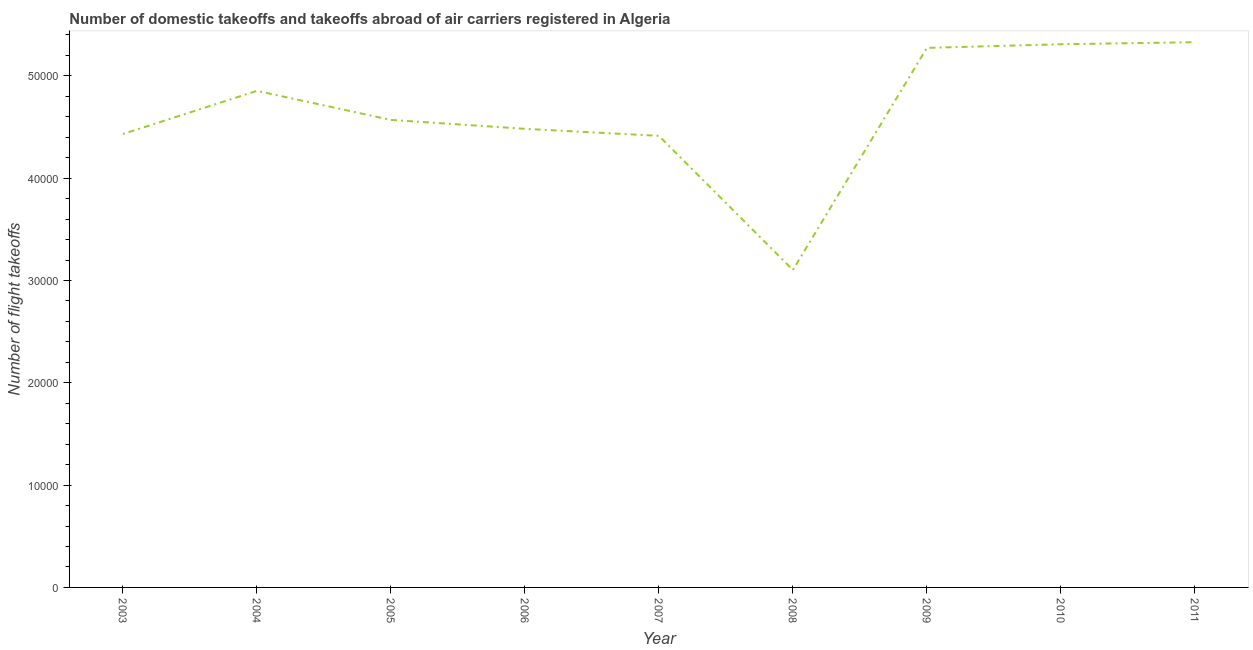What is the number of flight takeoffs in 2009?
Offer a very short reply. 5.27e+04. Across all years, what is the maximum number of flight takeoffs?
Give a very brief answer. 5.33e+04. Across all years, what is the minimum number of flight takeoffs?
Provide a short and direct response. 3.10e+04. In which year was the number of flight takeoffs maximum?
Your response must be concise. 2011. In which year was the number of flight takeoffs minimum?
Your answer should be very brief. 2008. What is the sum of the number of flight takeoffs?
Your answer should be compact. 4.18e+05. What is the difference between the number of flight takeoffs in 2005 and 2007?
Give a very brief answer. 1556. What is the average number of flight takeoffs per year?
Keep it short and to the point. 4.64e+04. What is the median number of flight takeoffs?
Offer a very short reply. 4.57e+04. In how many years, is the number of flight takeoffs greater than 22000 ?
Your response must be concise. 9. What is the ratio of the number of flight takeoffs in 2010 to that in 2011?
Your answer should be compact. 1. Is the number of flight takeoffs in 2007 less than that in 2011?
Keep it short and to the point. Yes. Is the difference between the number of flight takeoffs in 2007 and 2010 greater than the difference between any two years?
Give a very brief answer. No. What is the difference between the highest and the second highest number of flight takeoffs?
Your answer should be compact. 198. Is the sum of the number of flight takeoffs in 2007 and 2011 greater than the maximum number of flight takeoffs across all years?
Ensure brevity in your answer.  Yes. What is the difference between the highest and the lowest number of flight takeoffs?
Keep it short and to the point. 2.23e+04. Does the number of flight takeoffs monotonically increase over the years?
Your answer should be very brief. No. How many years are there in the graph?
Provide a short and direct response. 9. Are the values on the major ticks of Y-axis written in scientific E-notation?
Make the answer very short. No. What is the title of the graph?
Your response must be concise. Number of domestic takeoffs and takeoffs abroad of air carriers registered in Algeria. What is the label or title of the Y-axis?
Your answer should be compact. Number of flight takeoffs. What is the Number of flight takeoffs in 2003?
Your answer should be compact. 4.43e+04. What is the Number of flight takeoffs in 2004?
Your response must be concise. 4.85e+04. What is the Number of flight takeoffs in 2005?
Ensure brevity in your answer.  4.57e+04. What is the Number of flight takeoffs in 2006?
Give a very brief answer. 4.48e+04. What is the Number of flight takeoffs of 2007?
Provide a short and direct response. 4.41e+04. What is the Number of flight takeoffs in 2008?
Your answer should be compact. 3.10e+04. What is the Number of flight takeoffs of 2009?
Your response must be concise. 5.27e+04. What is the Number of flight takeoffs in 2010?
Keep it short and to the point. 5.31e+04. What is the Number of flight takeoffs of 2011?
Offer a terse response. 5.33e+04. What is the difference between the Number of flight takeoffs in 2003 and 2004?
Provide a short and direct response. -4216. What is the difference between the Number of flight takeoffs in 2003 and 2005?
Make the answer very short. -1377. What is the difference between the Number of flight takeoffs in 2003 and 2006?
Provide a succinct answer. -507. What is the difference between the Number of flight takeoffs in 2003 and 2007?
Make the answer very short. 179. What is the difference between the Number of flight takeoffs in 2003 and 2008?
Make the answer very short. 1.33e+04. What is the difference between the Number of flight takeoffs in 2003 and 2009?
Your response must be concise. -8416. What is the difference between the Number of flight takeoffs in 2003 and 2010?
Ensure brevity in your answer.  -8773. What is the difference between the Number of flight takeoffs in 2003 and 2011?
Your answer should be very brief. -8971. What is the difference between the Number of flight takeoffs in 2004 and 2005?
Your answer should be compact. 2839. What is the difference between the Number of flight takeoffs in 2004 and 2006?
Ensure brevity in your answer.  3709. What is the difference between the Number of flight takeoffs in 2004 and 2007?
Give a very brief answer. 4395. What is the difference between the Number of flight takeoffs in 2004 and 2008?
Give a very brief answer. 1.75e+04. What is the difference between the Number of flight takeoffs in 2004 and 2009?
Make the answer very short. -4200. What is the difference between the Number of flight takeoffs in 2004 and 2010?
Offer a very short reply. -4557. What is the difference between the Number of flight takeoffs in 2004 and 2011?
Provide a succinct answer. -4755. What is the difference between the Number of flight takeoffs in 2005 and 2006?
Make the answer very short. 870. What is the difference between the Number of flight takeoffs in 2005 and 2007?
Provide a short and direct response. 1556. What is the difference between the Number of flight takeoffs in 2005 and 2008?
Provide a succinct answer. 1.47e+04. What is the difference between the Number of flight takeoffs in 2005 and 2009?
Make the answer very short. -7039. What is the difference between the Number of flight takeoffs in 2005 and 2010?
Offer a very short reply. -7396. What is the difference between the Number of flight takeoffs in 2005 and 2011?
Keep it short and to the point. -7594. What is the difference between the Number of flight takeoffs in 2006 and 2007?
Make the answer very short. 686. What is the difference between the Number of flight takeoffs in 2006 and 2008?
Make the answer very short. 1.38e+04. What is the difference between the Number of flight takeoffs in 2006 and 2009?
Keep it short and to the point. -7909. What is the difference between the Number of flight takeoffs in 2006 and 2010?
Offer a very short reply. -8266. What is the difference between the Number of flight takeoffs in 2006 and 2011?
Your response must be concise. -8464. What is the difference between the Number of flight takeoffs in 2007 and 2008?
Make the answer very short. 1.31e+04. What is the difference between the Number of flight takeoffs in 2007 and 2009?
Give a very brief answer. -8595. What is the difference between the Number of flight takeoffs in 2007 and 2010?
Ensure brevity in your answer.  -8952. What is the difference between the Number of flight takeoffs in 2007 and 2011?
Offer a terse response. -9150. What is the difference between the Number of flight takeoffs in 2008 and 2009?
Your answer should be very brief. -2.17e+04. What is the difference between the Number of flight takeoffs in 2008 and 2010?
Provide a succinct answer. -2.21e+04. What is the difference between the Number of flight takeoffs in 2008 and 2011?
Provide a short and direct response. -2.23e+04. What is the difference between the Number of flight takeoffs in 2009 and 2010?
Your response must be concise. -357. What is the difference between the Number of flight takeoffs in 2009 and 2011?
Keep it short and to the point. -555. What is the difference between the Number of flight takeoffs in 2010 and 2011?
Provide a succinct answer. -198. What is the ratio of the Number of flight takeoffs in 2003 to that in 2005?
Offer a very short reply. 0.97. What is the ratio of the Number of flight takeoffs in 2003 to that in 2007?
Offer a very short reply. 1. What is the ratio of the Number of flight takeoffs in 2003 to that in 2008?
Give a very brief answer. 1.43. What is the ratio of the Number of flight takeoffs in 2003 to that in 2009?
Offer a very short reply. 0.84. What is the ratio of the Number of flight takeoffs in 2003 to that in 2010?
Keep it short and to the point. 0.83. What is the ratio of the Number of flight takeoffs in 2003 to that in 2011?
Your response must be concise. 0.83. What is the ratio of the Number of flight takeoffs in 2004 to that in 2005?
Ensure brevity in your answer.  1.06. What is the ratio of the Number of flight takeoffs in 2004 to that in 2006?
Offer a terse response. 1.08. What is the ratio of the Number of flight takeoffs in 2004 to that in 2007?
Provide a succinct answer. 1.1. What is the ratio of the Number of flight takeoffs in 2004 to that in 2008?
Your response must be concise. 1.56. What is the ratio of the Number of flight takeoffs in 2004 to that in 2010?
Give a very brief answer. 0.91. What is the ratio of the Number of flight takeoffs in 2004 to that in 2011?
Offer a very short reply. 0.91. What is the ratio of the Number of flight takeoffs in 2005 to that in 2007?
Provide a short and direct response. 1.03. What is the ratio of the Number of flight takeoffs in 2005 to that in 2008?
Offer a very short reply. 1.47. What is the ratio of the Number of flight takeoffs in 2005 to that in 2009?
Your answer should be compact. 0.87. What is the ratio of the Number of flight takeoffs in 2005 to that in 2010?
Keep it short and to the point. 0.86. What is the ratio of the Number of flight takeoffs in 2005 to that in 2011?
Offer a very short reply. 0.86. What is the ratio of the Number of flight takeoffs in 2006 to that in 2007?
Offer a terse response. 1.02. What is the ratio of the Number of flight takeoffs in 2006 to that in 2008?
Offer a terse response. 1.45. What is the ratio of the Number of flight takeoffs in 2006 to that in 2010?
Provide a succinct answer. 0.84. What is the ratio of the Number of flight takeoffs in 2006 to that in 2011?
Ensure brevity in your answer.  0.84. What is the ratio of the Number of flight takeoffs in 2007 to that in 2008?
Your response must be concise. 1.42. What is the ratio of the Number of flight takeoffs in 2007 to that in 2009?
Ensure brevity in your answer.  0.84. What is the ratio of the Number of flight takeoffs in 2007 to that in 2010?
Your response must be concise. 0.83. What is the ratio of the Number of flight takeoffs in 2007 to that in 2011?
Your answer should be compact. 0.83. What is the ratio of the Number of flight takeoffs in 2008 to that in 2009?
Your answer should be very brief. 0.59. What is the ratio of the Number of flight takeoffs in 2008 to that in 2010?
Give a very brief answer. 0.58. What is the ratio of the Number of flight takeoffs in 2008 to that in 2011?
Make the answer very short. 0.58. What is the ratio of the Number of flight takeoffs in 2009 to that in 2010?
Keep it short and to the point. 0.99. What is the ratio of the Number of flight takeoffs in 2010 to that in 2011?
Give a very brief answer. 1. 